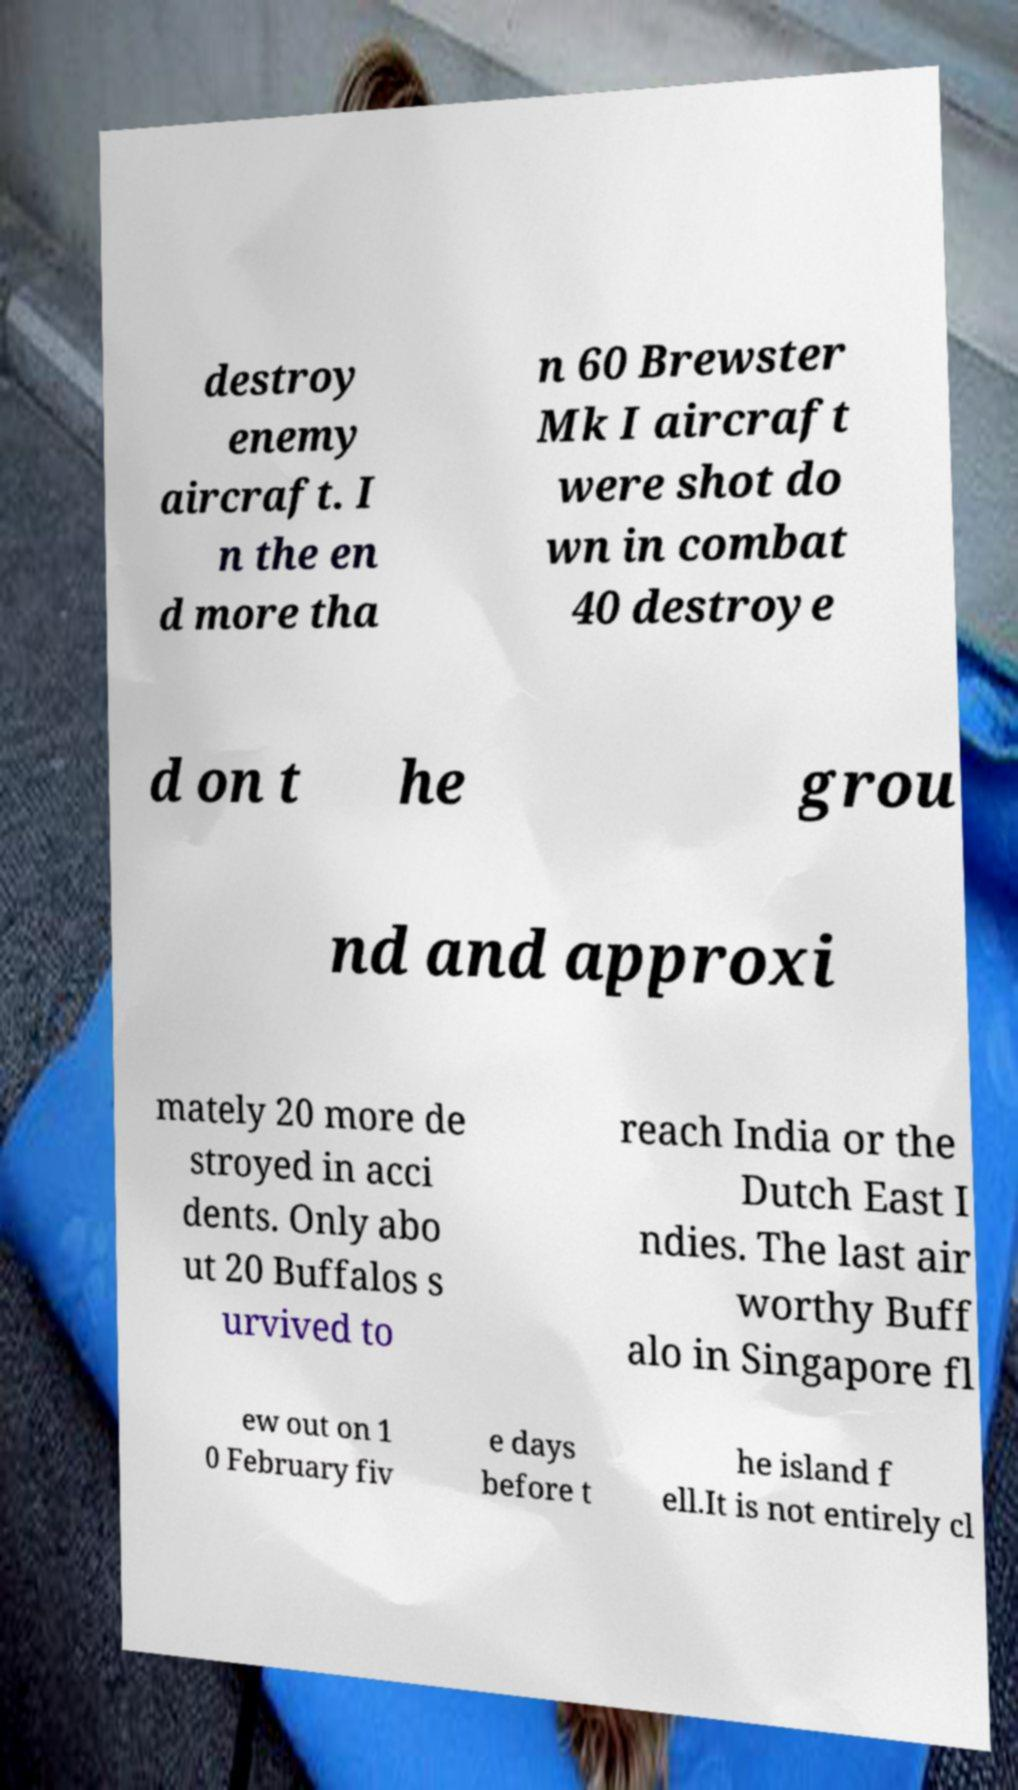Please identify and transcribe the text found in this image. destroy enemy aircraft. I n the en d more tha n 60 Brewster Mk I aircraft were shot do wn in combat 40 destroye d on t he grou nd and approxi mately 20 more de stroyed in acci dents. Only abo ut 20 Buffalos s urvived to reach India or the Dutch East I ndies. The last air worthy Buff alo in Singapore fl ew out on 1 0 February fiv e days before t he island f ell.It is not entirely cl 